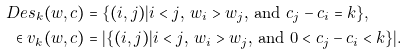<formula> <loc_0><loc_0><loc_500><loc_500>\ D e s _ { k } ( w , c ) & = \{ ( i , j ) | \text {$i<j$, $w_{i}>w_{j}$, and $c_{j}-c_{i}=k$} \} , \\ \in v _ { k } ( w , c ) & = | \{ ( i , j ) | \text {$i<j$, $w_{i}>w_{j}$, and $0<c_{j}-c_{i}<k$} \} | .</formula> 